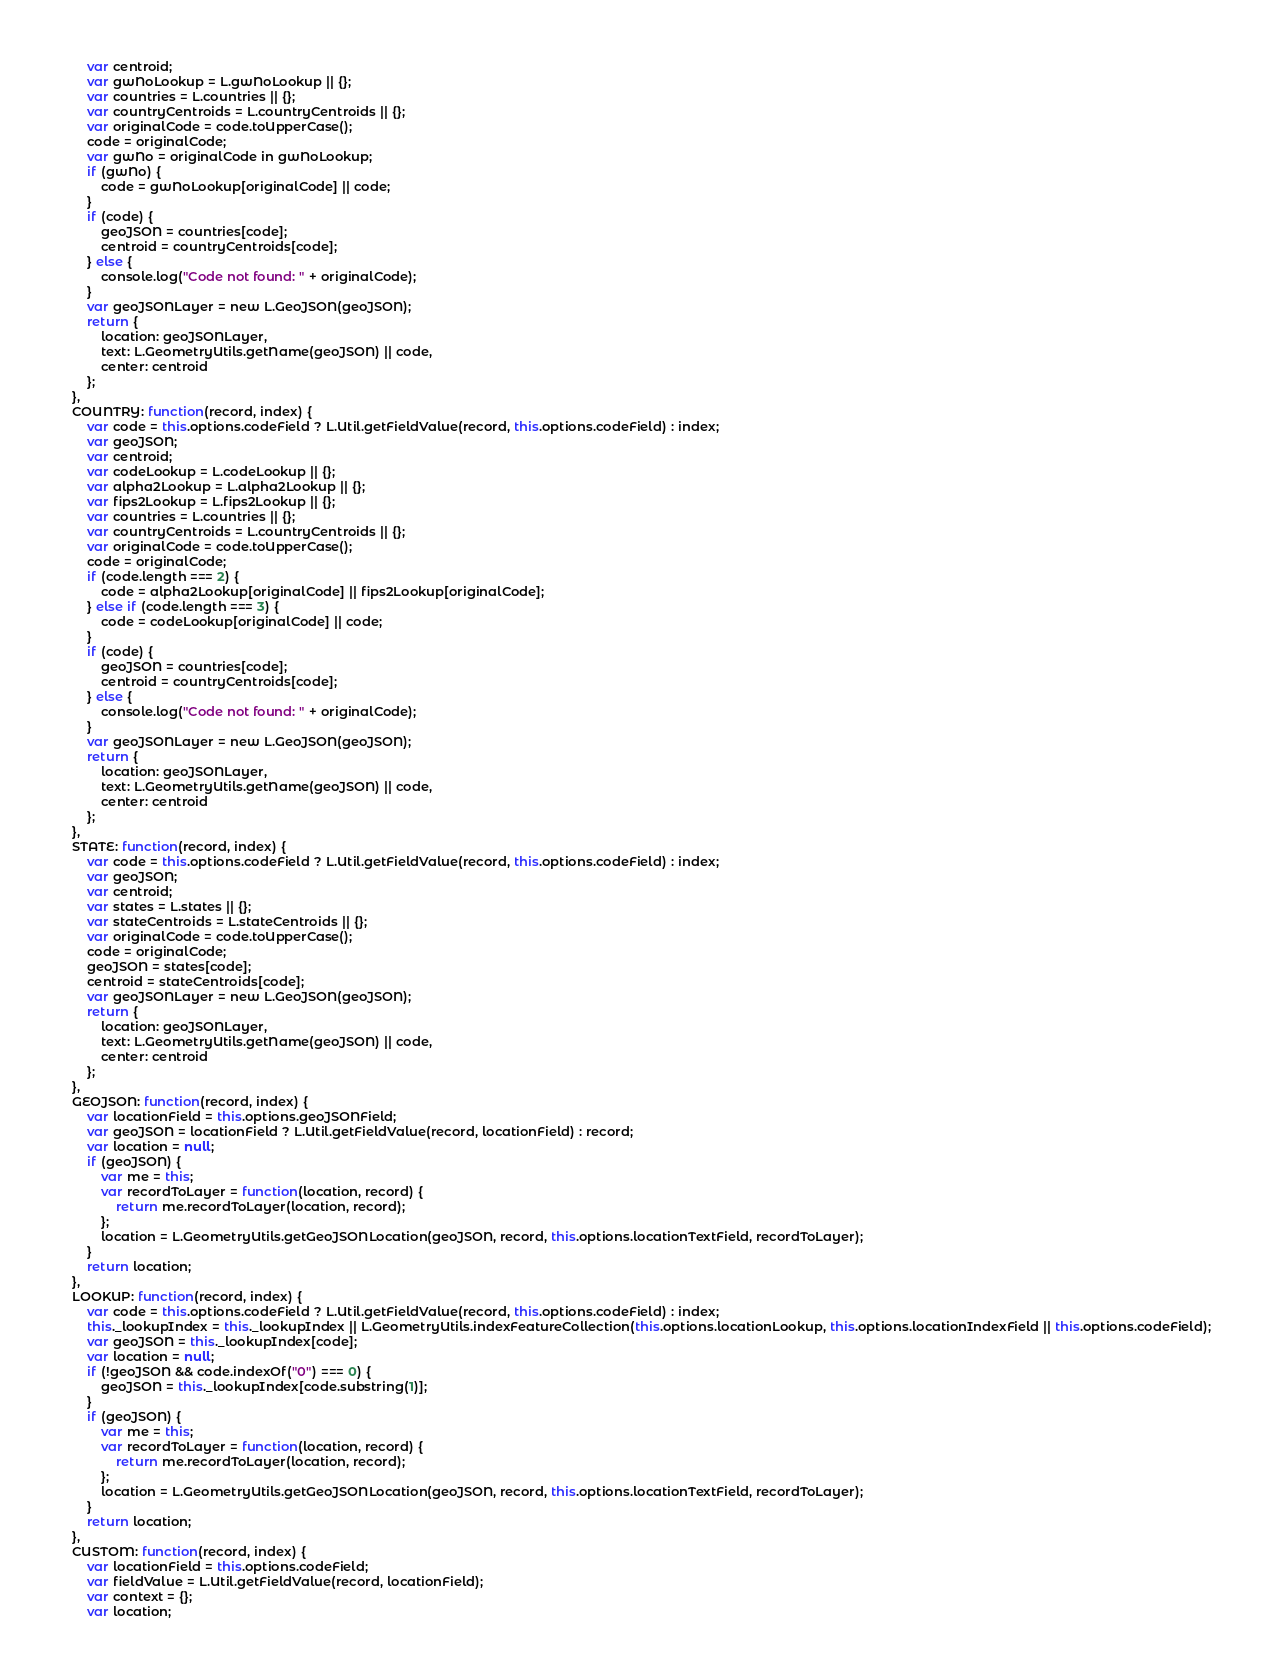Convert code to text. <code><loc_0><loc_0><loc_500><loc_500><_JavaScript_>        var centroid;
        var gwNoLookup = L.gwNoLookup || {};
        var countries = L.countries || {};
        var countryCentroids = L.countryCentroids || {};
        var originalCode = code.toUpperCase();
        code = originalCode;
        var gwNo = originalCode in gwNoLookup;
        if (gwNo) {
            code = gwNoLookup[originalCode] || code;
        }
        if (code) {
            geoJSON = countries[code];
            centroid = countryCentroids[code];
        } else {
            console.log("Code not found: " + originalCode);
        }
        var geoJSONLayer = new L.GeoJSON(geoJSON);
        return {
            location: geoJSONLayer,
            text: L.GeometryUtils.getName(geoJSON) || code,
            center: centroid
        };
    },
    COUNTRY: function(record, index) {
        var code = this.options.codeField ? L.Util.getFieldValue(record, this.options.codeField) : index;
        var geoJSON;
        var centroid;
        var codeLookup = L.codeLookup || {};
        var alpha2Lookup = L.alpha2Lookup || {};
        var fips2Lookup = L.fips2Lookup || {};
        var countries = L.countries || {};
        var countryCentroids = L.countryCentroids || {};
        var originalCode = code.toUpperCase();
        code = originalCode;
        if (code.length === 2) {
            code = alpha2Lookup[originalCode] || fips2Lookup[originalCode];
        } else if (code.length === 3) {
            code = codeLookup[originalCode] || code;
        }
        if (code) {
            geoJSON = countries[code];
            centroid = countryCentroids[code];
        } else {
            console.log("Code not found: " + originalCode);
        }
        var geoJSONLayer = new L.GeoJSON(geoJSON);
        return {
            location: geoJSONLayer,
            text: L.GeometryUtils.getName(geoJSON) || code,
            center: centroid
        };
    },
    STATE: function(record, index) {
        var code = this.options.codeField ? L.Util.getFieldValue(record, this.options.codeField) : index;
        var geoJSON;
        var centroid;
        var states = L.states || {};
        var stateCentroids = L.stateCentroids || {};
        var originalCode = code.toUpperCase();
        code = originalCode;
        geoJSON = states[code];
        centroid = stateCentroids[code];
        var geoJSONLayer = new L.GeoJSON(geoJSON);
        return {
            location: geoJSONLayer,
            text: L.GeometryUtils.getName(geoJSON) || code,
            center: centroid
        };
    },
    GEOJSON: function(record, index) {
        var locationField = this.options.geoJSONField;
        var geoJSON = locationField ? L.Util.getFieldValue(record, locationField) : record;
        var location = null;
        if (geoJSON) {
            var me = this;
            var recordToLayer = function(location, record) {
                return me.recordToLayer(location, record);
            };
            location = L.GeometryUtils.getGeoJSONLocation(geoJSON, record, this.options.locationTextField, recordToLayer);
        }
        return location;
    },
    LOOKUP: function(record, index) {
        var code = this.options.codeField ? L.Util.getFieldValue(record, this.options.codeField) : index;
        this._lookupIndex = this._lookupIndex || L.GeometryUtils.indexFeatureCollection(this.options.locationLookup, this.options.locationIndexField || this.options.codeField);
        var geoJSON = this._lookupIndex[code];
        var location = null;
        if (!geoJSON && code.indexOf("0") === 0) {
            geoJSON = this._lookupIndex[code.substring(1)];
        }
        if (geoJSON) {
            var me = this;
            var recordToLayer = function(location, record) {
                return me.recordToLayer(location, record);
            };
            location = L.GeometryUtils.getGeoJSONLocation(geoJSON, record, this.options.locationTextField, recordToLayer);
        }
        return location;
    },
    CUSTOM: function(record, index) {
        var locationField = this.options.codeField;
        var fieldValue = L.Util.getFieldValue(record, locationField);
        var context = {};
        var location;</code> 